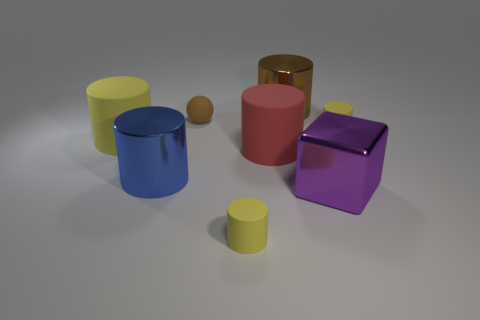Assess the relative sizes of the objects. Which is the largest and which is the smallest? The largest object seems to be the blue cylinder, based on its proportion relative to the other items. The smallest object is the small orange sphere positioned between the blue cylinder and the red rubber-like object. 